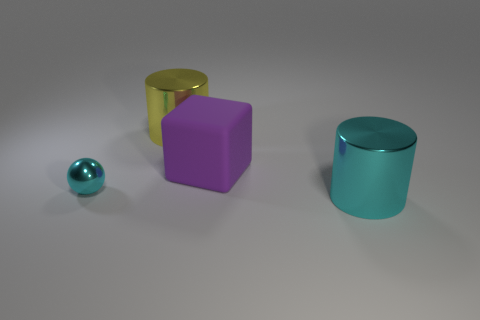Add 2 big yellow things. How many objects exist? 6 Subtract all cubes. How many objects are left? 3 Add 1 cyan cylinders. How many cyan cylinders are left? 2 Add 3 big yellow cylinders. How many big yellow cylinders exist? 4 Subtract 0 red cylinders. How many objects are left? 4 Subtract all brown matte cubes. Subtract all big metallic cylinders. How many objects are left? 2 